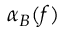Convert formula to latex. <formula><loc_0><loc_0><loc_500><loc_500>\alpha _ { B } ( f )</formula> 